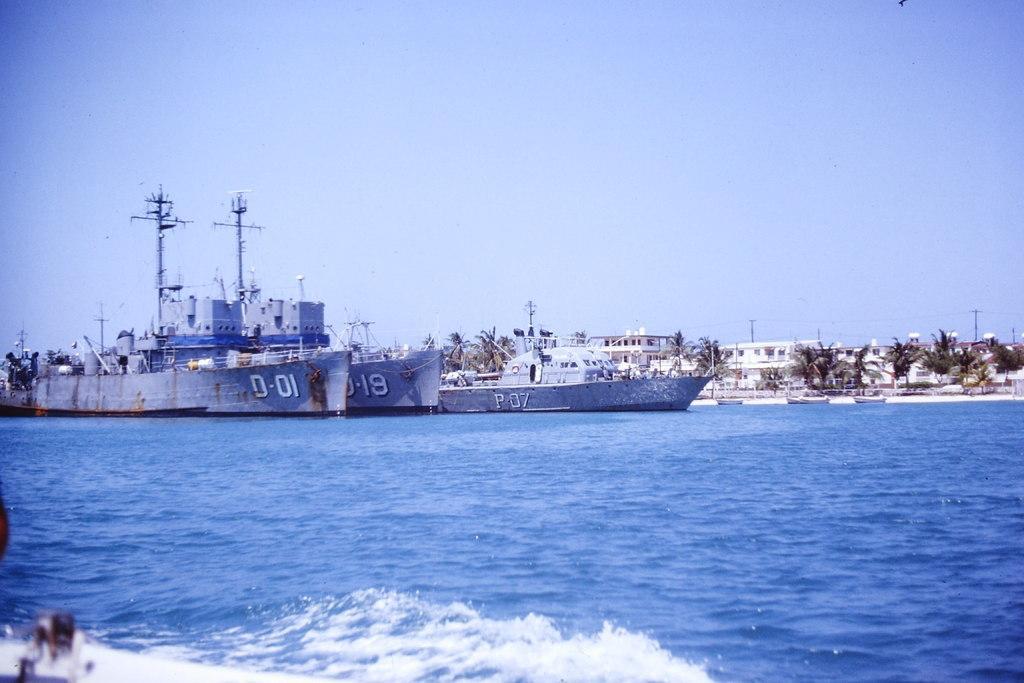Describe this image in one or two sentences. In this picture there is water at the bottom side of the image and there are ships and trees in the center of the image. 